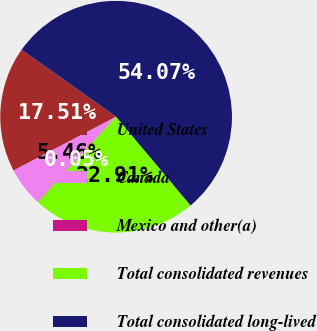Convert chart to OTSL. <chart><loc_0><loc_0><loc_500><loc_500><pie_chart><fcel>United States<fcel>Canada<fcel>Mexico and other(a)<fcel>Total consolidated revenues<fcel>Total consolidated long-lived<nl><fcel>17.51%<fcel>5.46%<fcel>0.05%<fcel>22.91%<fcel>54.08%<nl></chart> 